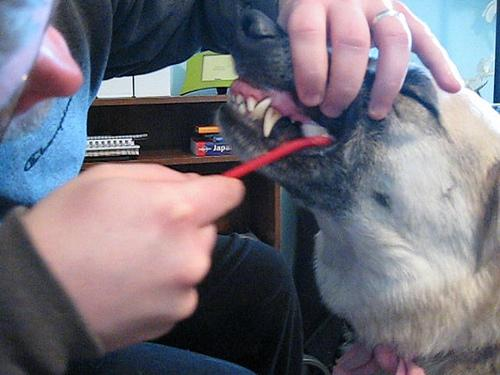Question: who is next to the dog?
Choices:
A. A cat.
B. A bird.
C. A snake.
D. A person.
Answer with the letter. Answer: D Question: what is the dog doing?
Choices:
A. Sitting there.
B. Playing.
C. Begging.
D. Laying down.
Answer with the letter. Answer: A Question: what color is the dog?
Choices:
A. Brown and white.
B. Black and white.
C. Brown and black.
D. Black and gray.
Answer with the letter. Answer: C Question: how many dogs are there?
Choices:
A. Zero.
B. Two.
C. One.
D. Three.
Answer with the letter. Answer: C 